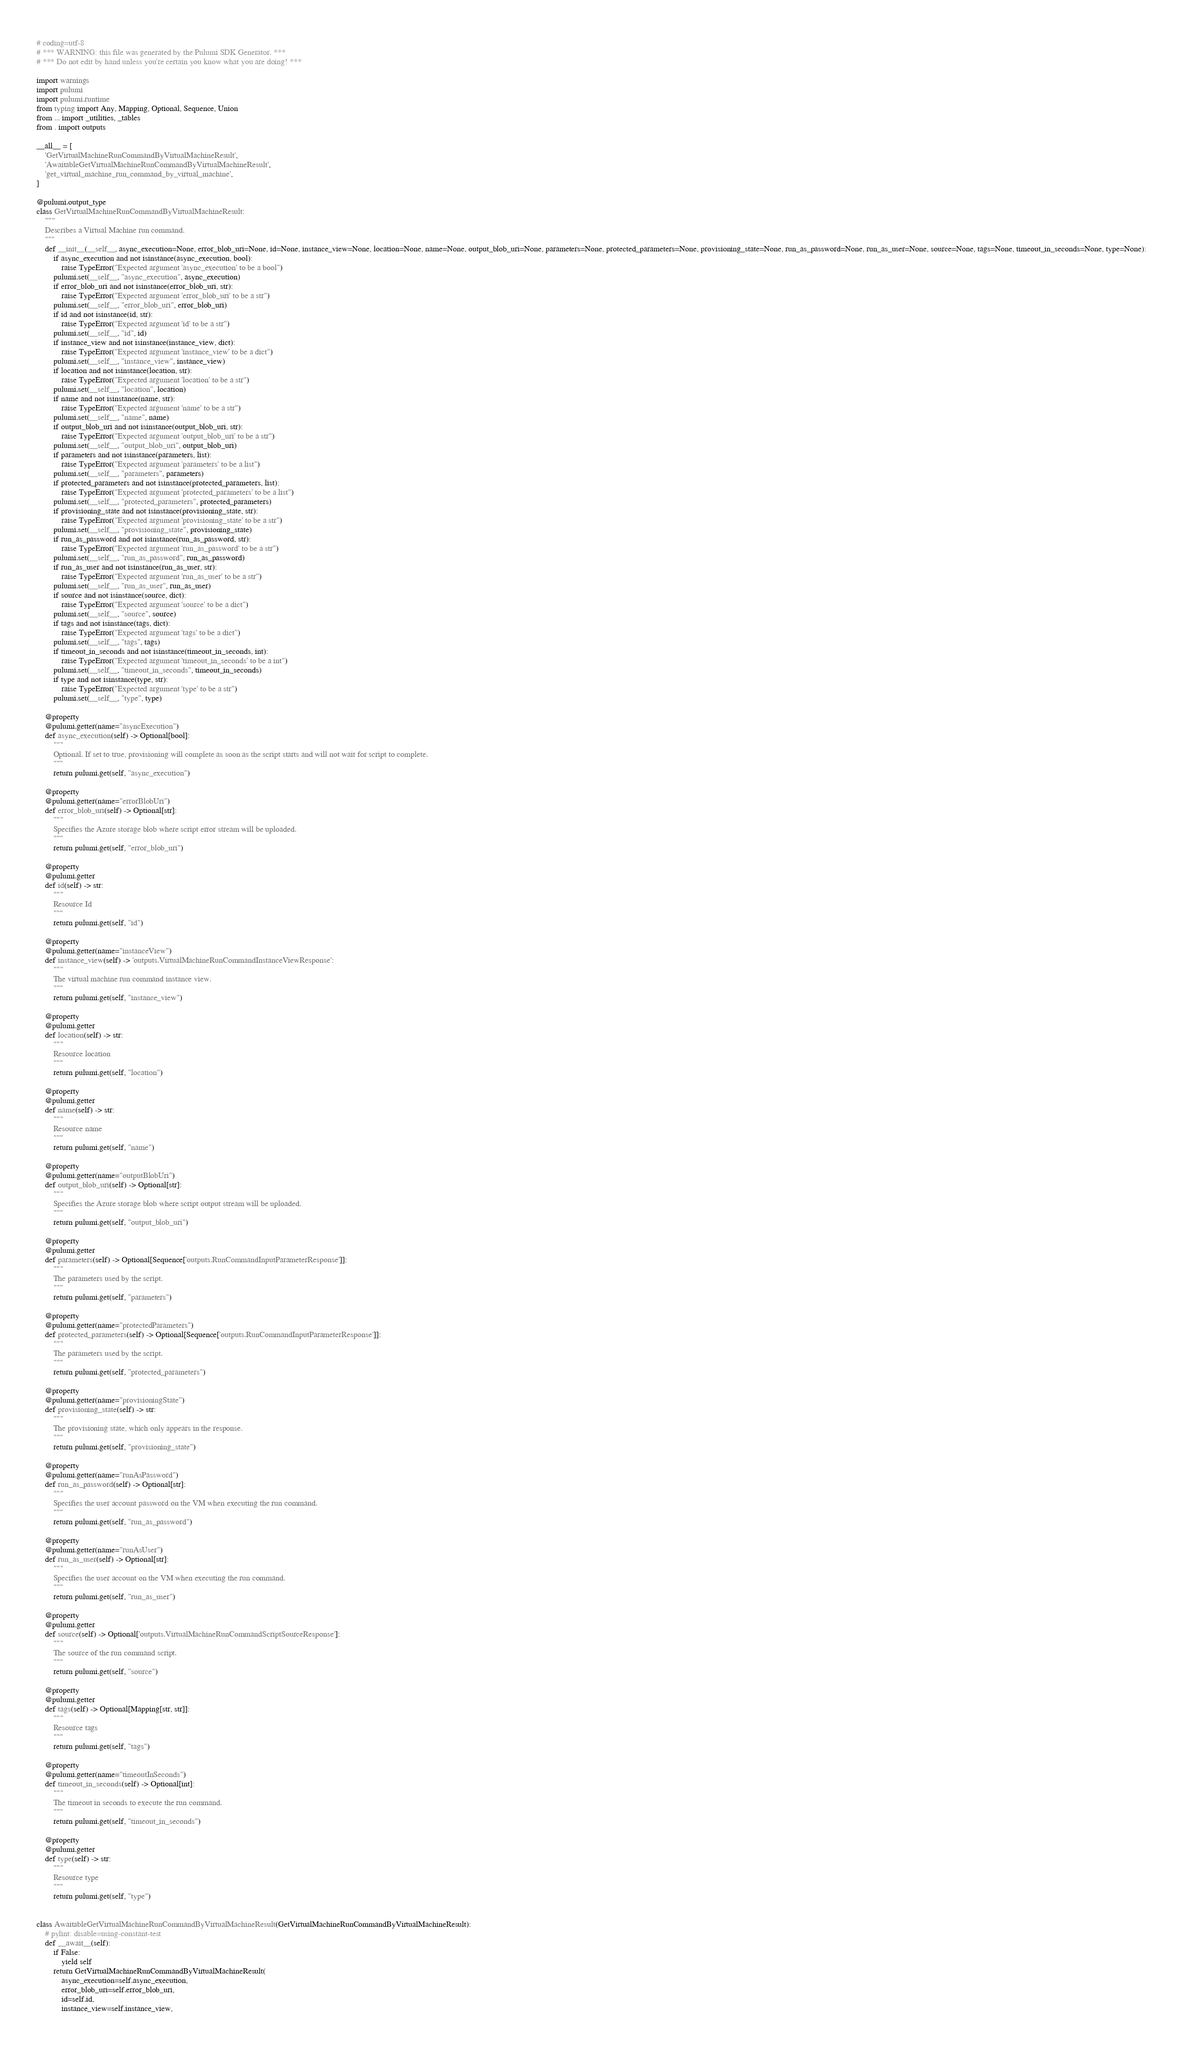<code> <loc_0><loc_0><loc_500><loc_500><_Python_># coding=utf-8
# *** WARNING: this file was generated by the Pulumi SDK Generator. ***
# *** Do not edit by hand unless you're certain you know what you are doing! ***

import warnings
import pulumi
import pulumi.runtime
from typing import Any, Mapping, Optional, Sequence, Union
from ... import _utilities, _tables
from . import outputs

__all__ = [
    'GetVirtualMachineRunCommandByVirtualMachineResult',
    'AwaitableGetVirtualMachineRunCommandByVirtualMachineResult',
    'get_virtual_machine_run_command_by_virtual_machine',
]

@pulumi.output_type
class GetVirtualMachineRunCommandByVirtualMachineResult:
    """
    Describes a Virtual Machine run command.
    """
    def __init__(__self__, async_execution=None, error_blob_uri=None, id=None, instance_view=None, location=None, name=None, output_blob_uri=None, parameters=None, protected_parameters=None, provisioning_state=None, run_as_password=None, run_as_user=None, source=None, tags=None, timeout_in_seconds=None, type=None):
        if async_execution and not isinstance(async_execution, bool):
            raise TypeError("Expected argument 'async_execution' to be a bool")
        pulumi.set(__self__, "async_execution", async_execution)
        if error_blob_uri and not isinstance(error_blob_uri, str):
            raise TypeError("Expected argument 'error_blob_uri' to be a str")
        pulumi.set(__self__, "error_blob_uri", error_blob_uri)
        if id and not isinstance(id, str):
            raise TypeError("Expected argument 'id' to be a str")
        pulumi.set(__self__, "id", id)
        if instance_view and not isinstance(instance_view, dict):
            raise TypeError("Expected argument 'instance_view' to be a dict")
        pulumi.set(__self__, "instance_view", instance_view)
        if location and not isinstance(location, str):
            raise TypeError("Expected argument 'location' to be a str")
        pulumi.set(__self__, "location", location)
        if name and not isinstance(name, str):
            raise TypeError("Expected argument 'name' to be a str")
        pulumi.set(__self__, "name", name)
        if output_blob_uri and not isinstance(output_blob_uri, str):
            raise TypeError("Expected argument 'output_blob_uri' to be a str")
        pulumi.set(__self__, "output_blob_uri", output_blob_uri)
        if parameters and not isinstance(parameters, list):
            raise TypeError("Expected argument 'parameters' to be a list")
        pulumi.set(__self__, "parameters", parameters)
        if protected_parameters and not isinstance(protected_parameters, list):
            raise TypeError("Expected argument 'protected_parameters' to be a list")
        pulumi.set(__self__, "protected_parameters", protected_parameters)
        if provisioning_state and not isinstance(provisioning_state, str):
            raise TypeError("Expected argument 'provisioning_state' to be a str")
        pulumi.set(__self__, "provisioning_state", provisioning_state)
        if run_as_password and not isinstance(run_as_password, str):
            raise TypeError("Expected argument 'run_as_password' to be a str")
        pulumi.set(__self__, "run_as_password", run_as_password)
        if run_as_user and not isinstance(run_as_user, str):
            raise TypeError("Expected argument 'run_as_user' to be a str")
        pulumi.set(__self__, "run_as_user", run_as_user)
        if source and not isinstance(source, dict):
            raise TypeError("Expected argument 'source' to be a dict")
        pulumi.set(__self__, "source", source)
        if tags and not isinstance(tags, dict):
            raise TypeError("Expected argument 'tags' to be a dict")
        pulumi.set(__self__, "tags", tags)
        if timeout_in_seconds and not isinstance(timeout_in_seconds, int):
            raise TypeError("Expected argument 'timeout_in_seconds' to be a int")
        pulumi.set(__self__, "timeout_in_seconds", timeout_in_seconds)
        if type and not isinstance(type, str):
            raise TypeError("Expected argument 'type' to be a str")
        pulumi.set(__self__, "type", type)

    @property
    @pulumi.getter(name="asyncExecution")
    def async_execution(self) -> Optional[bool]:
        """
        Optional. If set to true, provisioning will complete as soon as the script starts and will not wait for script to complete.
        """
        return pulumi.get(self, "async_execution")

    @property
    @pulumi.getter(name="errorBlobUri")
    def error_blob_uri(self) -> Optional[str]:
        """
        Specifies the Azure storage blob where script error stream will be uploaded.
        """
        return pulumi.get(self, "error_blob_uri")

    @property
    @pulumi.getter
    def id(self) -> str:
        """
        Resource Id
        """
        return pulumi.get(self, "id")

    @property
    @pulumi.getter(name="instanceView")
    def instance_view(self) -> 'outputs.VirtualMachineRunCommandInstanceViewResponse':
        """
        The virtual machine run command instance view.
        """
        return pulumi.get(self, "instance_view")

    @property
    @pulumi.getter
    def location(self) -> str:
        """
        Resource location
        """
        return pulumi.get(self, "location")

    @property
    @pulumi.getter
    def name(self) -> str:
        """
        Resource name
        """
        return pulumi.get(self, "name")

    @property
    @pulumi.getter(name="outputBlobUri")
    def output_blob_uri(self) -> Optional[str]:
        """
        Specifies the Azure storage blob where script output stream will be uploaded.
        """
        return pulumi.get(self, "output_blob_uri")

    @property
    @pulumi.getter
    def parameters(self) -> Optional[Sequence['outputs.RunCommandInputParameterResponse']]:
        """
        The parameters used by the script.
        """
        return pulumi.get(self, "parameters")

    @property
    @pulumi.getter(name="protectedParameters")
    def protected_parameters(self) -> Optional[Sequence['outputs.RunCommandInputParameterResponse']]:
        """
        The parameters used by the script.
        """
        return pulumi.get(self, "protected_parameters")

    @property
    @pulumi.getter(name="provisioningState")
    def provisioning_state(self) -> str:
        """
        The provisioning state, which only appears in the response.
        """
        return pulumi.get(self, "provisioning_state")

    @property
    @pulumi.getter(name="runAsPassword")
    def run_as_password(self) -> Optional[str]:
        """
        Specifies the user account password on the VM when executing the run command.
        """
        return pulumi.get(self, "run_as_password")

    @property
    @pulumi.getter(name="runAsUser")
    def run_as_user(self) -> Optional[str]:
        """
        Specifies the user account on the VM when executing the run command.
        """
        return pulumi.get(self, "run_as_user")

    @property
    @pulumi.getter
    def source(self) -> Optional['outputs.VirtualMachineRunCommandScriptSourceResponse']:
        """
        The source of the run command script.
        """
        return pulumi.get(self, "source")

    @property
    @pulumi.getter
    def tags(self) -> Optional[Mapping[str, str]]:
        """
        Resource tags
        """
        return pulumi.get(self, "tags")

    @property
    @pulumi.getter(name="timeoutInSeconds")
    def timeout_in_seconds(self) -> Optional[int]:
        """
        The timeout in seconds to execute the run command.
        """
        return pulumi.get(self, "timeout_in_seconds")

    @property
    @pulumi.getter
    def type(self) -> str:
        """
        Resource type
        """
        return pulumi.get(self, "type")


class AwaitableGetVirtualMachineRunCommandByVirtualMachineResult(GetVirtualMachineRunCommandByVirtualMachineResult):
    # pylint: disable=using-constant-test
    def __await__(self):
        if False:
            yield self
        return GetVirtualMachineRunCommandByVirtualMachineResult(
            async_execution=self.async_execution,
            error_blob_uri=self.error_blob_uri,
            id=self.id,
            instance_view=self.instance_view,</code> 